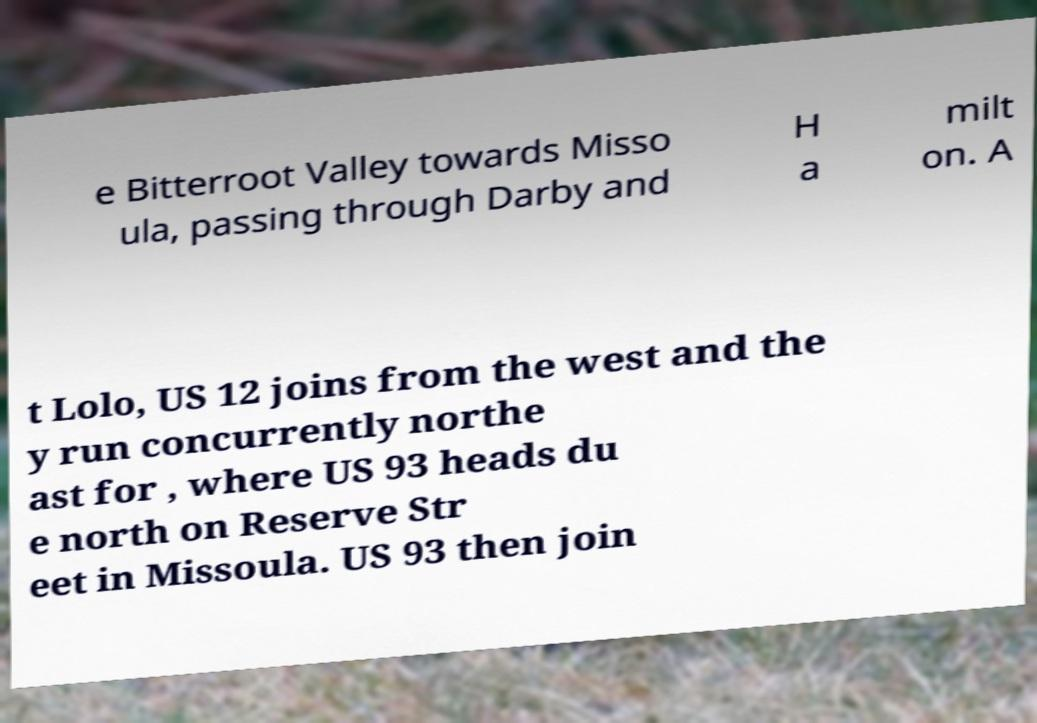Can you accurately transcribe the text from the provided image for me? e Bitterroot Valley towards Misso ula, passing through Darby and H a milt on. A t Lolo, US 12 joins from the west and the y run concurrently northe ast for , where US 93 heads du e north on Reserve Str eet in Missoula. US 93 then join 